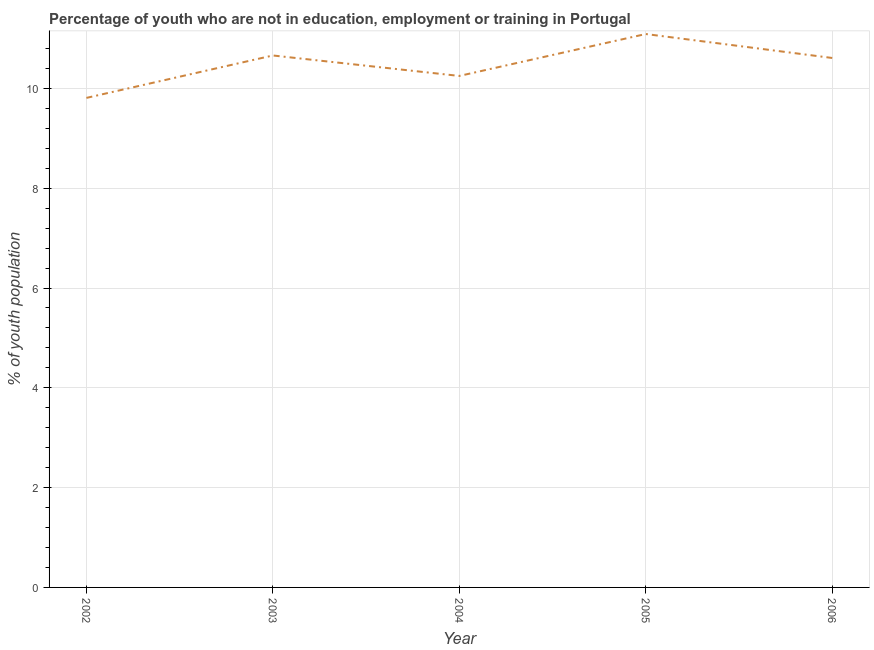What is the unemployed youth population in 2002?
Keep it short and to the point. 9.81. Across all years, what is the maximum unemployed youth population?
Provide a short and direct response. 11.09. Across all years, what is the minimum unemployed youth population?
Offer a terse response. 9.81. In which year was the unemployed youth population maximum?
Provide a short and direct response. 2005. In which year was the unemployed youth population minimum?
Provide a succinct answer. 2002. What is the sum of the unemployed youth population?
Your answer should be compact. 52.42. What is the difference between the unemployed youth population in 2002 and 2004?
Provide a succinct answer. -0.44. What is the average unemployed youth population per year?
Your answer should be compact. 10.48. What is the median unemployed youth population?
Provide a short and direct response. 10.61. In how many years, is the unemployed youth population greater than 4 %?
Make the answer very short. 5. What is the ratio of the unemployed youth population in 2002 to that in 2004?
Ensure brevity in your answer.  0.96. What is the difference between the highest and the second highest unemployed youth population?
Ensure brevity in your answer.  0.43. Is the sum of the unemployed youth population in 2004 and 2005 greater than the maximum unemployed youth population across all years?
Your answer should be compact. Yes. What is the difference between the highest and the lowest unemployed youth population?
Your answer should be compact. 1.28. Does the unemployed youth population monotonically increase over the years?
Provide a succinct answer. No. How many lines are there?
Your answer should be compact. 1. How many years are there in the graph?
Offer a terse response. 5. What is the difference between two consecutive major ticks on the Y-axis?
Your answer should be very brief. 2. Does the graph contain grids?
Provide a succinct answer. Yes. What is the title of the graph?
Ensure brevity in your answer.  Percentage of youth who are not in education, employment or training in Portugal. What is the label or title of the Y-axis?
Offer a very short reply. % of youth population. What is the % of youth population in 2002?
Provide a succinct answer. 9.81. What is the % of youth population in 2003?
Your answer should be very brief. 10.66. What is the % of youth population in 2004?
Your answer should be very brief. 10.25. What is the % of youth population in 2005?
Ensure brevity in your answer.  11.09. What is the % of youth population of 2006?
Your response must be concise. 10.61. What is the difference between the % of youth population in 2002 and 2003?
Provide a short and direct response. -0.85. What is the difference between the % of youth population in 2002 and 2004?
Keep it short and to the point. -0.44. What is the difference between the % of youth population in 2002 and 2005?
Offer a terse response. -1.28. What is the difference between the % of youth population in 2003 and 2004?
Keep it short and to the point. 0.41. What is the difference between the % of youth population in 2003 and 2005?
Your response must be concise. -0.43. What is the difference between the % of youth population in 2004 and 2005?
Ensure brevity in your answer.  -0.84. What is the difference between the % of youth population in 2004 and 2006?
Your answer should be compact. -0.36. What is the difference between the % of youth population in 2005 and 2006?
Give a very brief answer. 0.48. What is the ratio of the % of youth population in 2002 to that in 2005?
Give a very brief answer. 0.89. What is the ratio of the % of youth population in 2002 to that in 2006?
Give a very brief answer. 0.93. What is the ratio of the % of youth population in 2003 to that in 2004?
Ensure brevity in your answer.  1.04. What is the ratio of the % of youth population in 2003 to that in 2006?
Provide a succinct answer. 1. What is the ratio of the % of youth population in 2004 to that in 2005?
Your answer should be compact. 0.92. What is the ratio of the % of youth population in 2005 to that in 2006?
Provide a short and direct response. 1.04. 